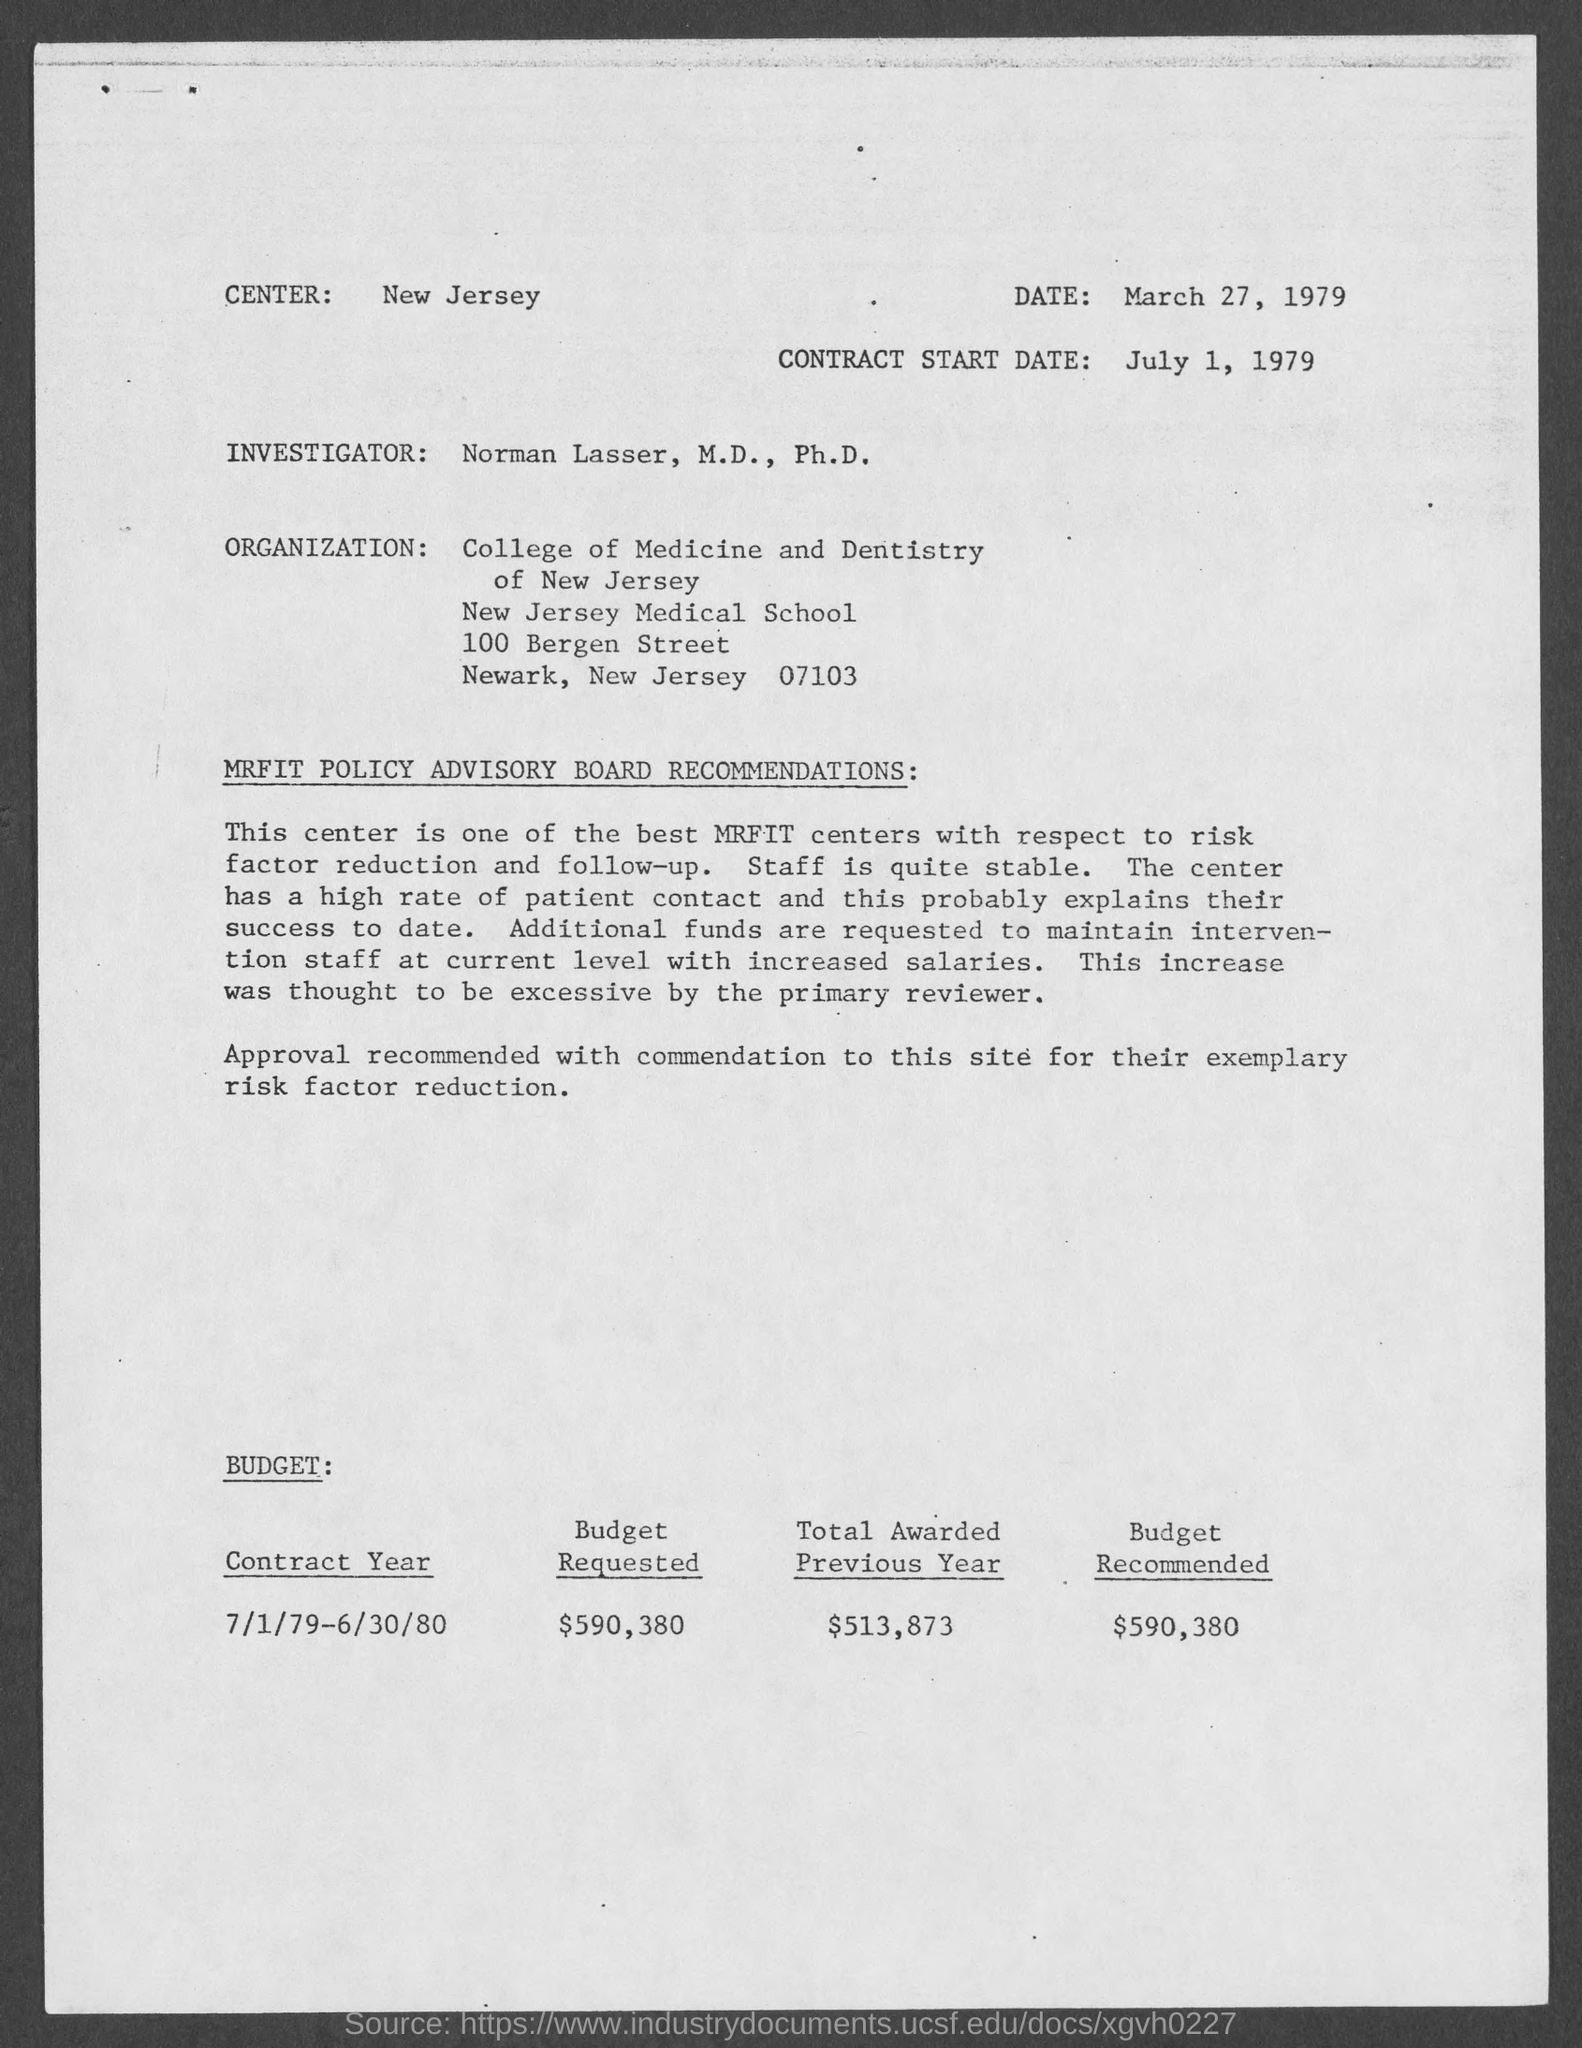Draw attention to some important aspects in this diagram. The budget for the contract year 7/1/79-6/30/80 is $590,380. The center mentioned in the document is New Jersey. Norman Lasser, M.D., Ph.D., is the investigator as per the document. The contract start date mentioned in the document is July 1, 1979. 